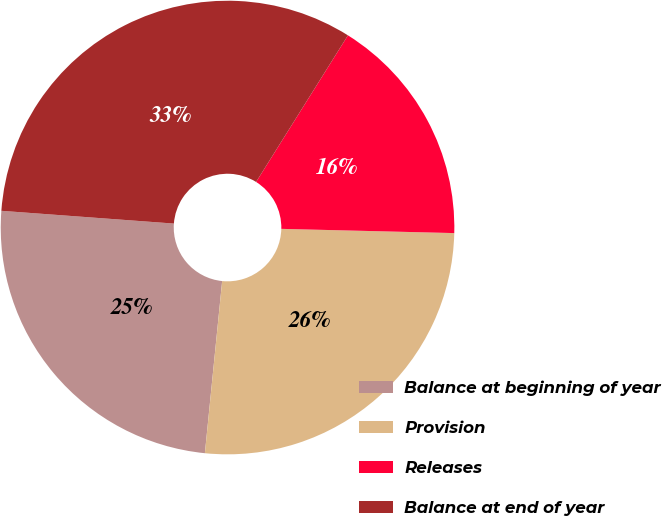Convert chart to OTSL. <chart><loc_0><loc_0><loc_500><loc_500><pie_chart><fcel>Balance at beginning of year<fcel>Provision<fcel>Releases<fcel>Balance at end of year<nl><fcel>24.58%<fcel>26.2%<fcel>16.48%<fcel>32.73%<nl></chart> 